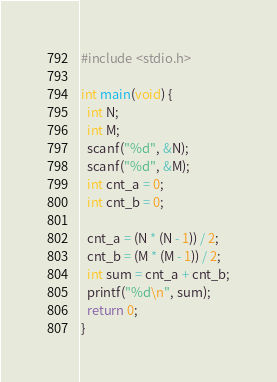<code> <loc_0><loc_0><loc_500><loc_500><_C_>#include <stdio.h>

int main(void) {
  int N;
  int M;
  scanf("%d", &N);
  scanf("%d", &M);
  int cnt_a = 0;
  int cnt_b = 0;

  cnt_a = (N * (N - 1)) / 2;
  cnt_b = (M * (M - 1)) / 2;
  int sum = cnt_a + cnt_b;
  printf("%d\n", sum);
  return 0;
}</code> 